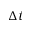<formula> <loc_0><loc_0><loc_500><loc_500>\Delta t</formula> 